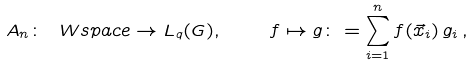<formula> <loc_0><loc_0><loc_500><loc_500>A _ { n } \colon \ W s p a c e \to L _ { q } ( G ) , \quad f \mapsto g \colon = \sum _ { i = 1 } ^ { n } f ( \vec { x } _ { i } ) \, g _ { i } \, ,</formula> 